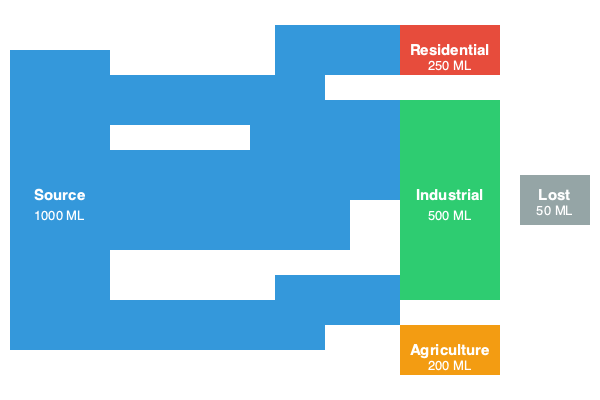Based on the Sankey diagram of water distribution in a smart city, calculate the water management efficiency. If the city implements a new leak detection system that reduces water loss by 60%, what would be the new efficiency percentage? To solve this problem, let's follow these steps:

1. Calculate the total water input:
   Total water = 1000 ML (Mega Liters)

2. Calculate the total water utilized:
   Utilized water = Residential + Industrial + Agriculture
                  = 250 ML + 500 ML + 200 ML = 950 ML

3. Calculate the current water loss:
   Current water loss = 50 ML

4. Calculate the current water management efficiency:
   Current efficiency = (Utilized water / Total water) × 100%
                      = (950 ML / 1000 ML) × 100% = 95%

5. Calculate the new water loss after implementing the leak detection system:
   New water loss = Current water loss × (1 - Reduction percentage)
                  = 50 ML × (1 - 0.60) = 20 ML

6. Calculate the new utilized water:
   New utilized water = Total water - New water loss
                      = 1000 ML - 20 ML = 980 ML

7. Calculate the new water management efficiency:
   New efficiency = (New utilized water / Total water) × 100%
                  = (980 ML / 1000 ML) × 100% = 98%

Therefore, the new water management efficiency after implementing the leak detection system would be 98%.
Answer: 98% 